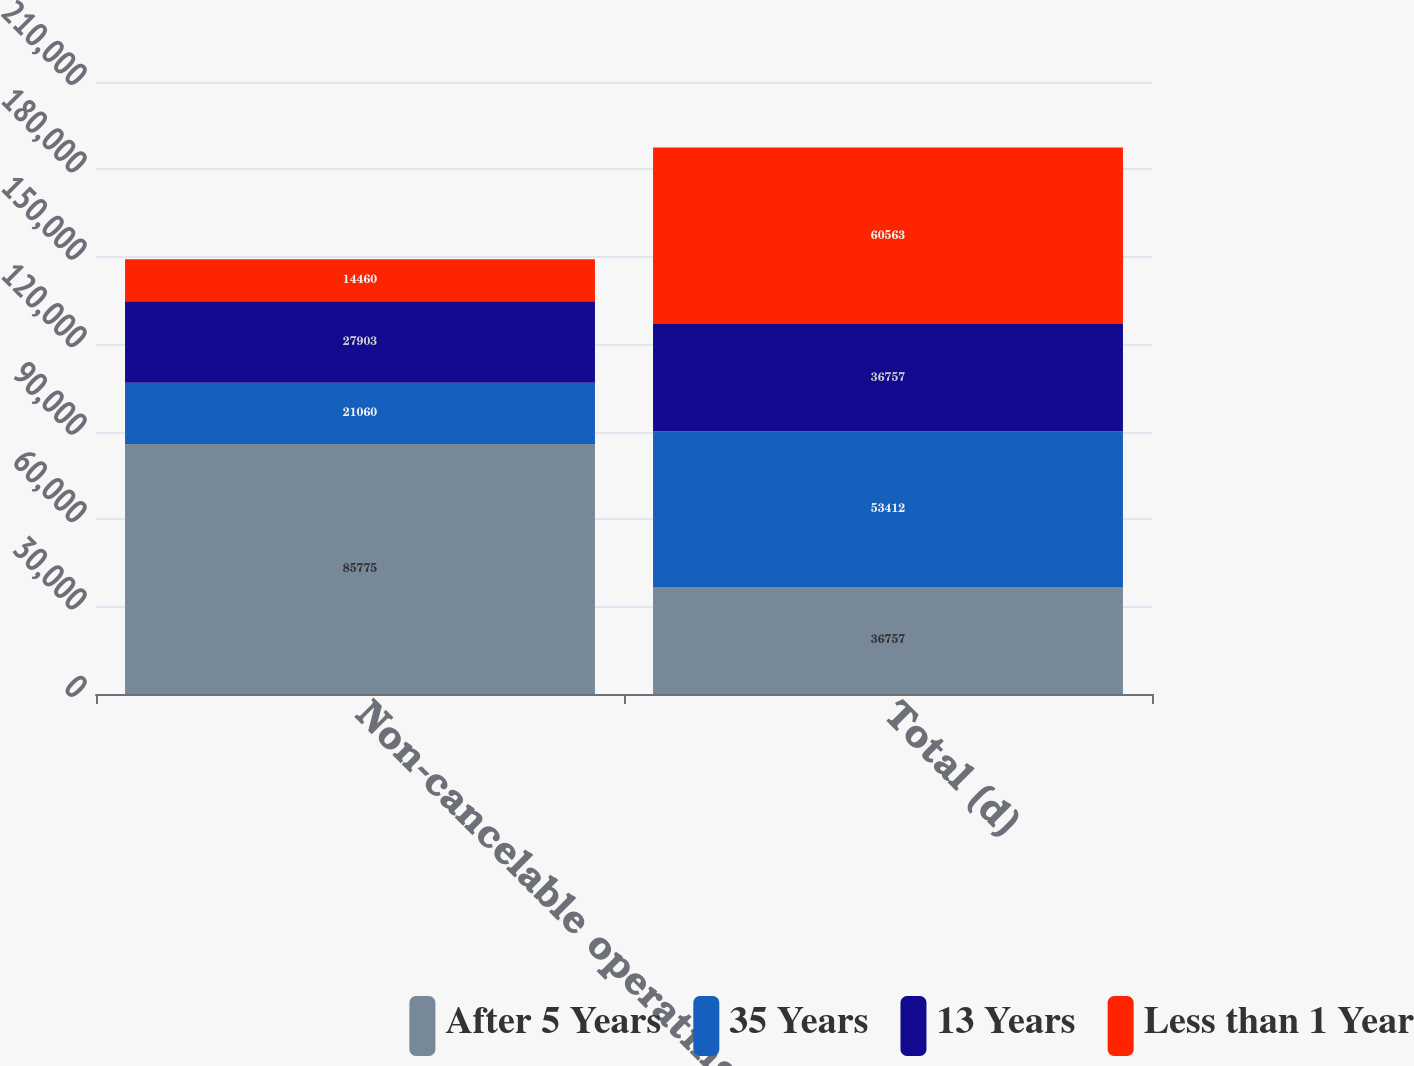Convert chart. <chart><loc_0><loc_0><loc_500><loc_500><stacked_bar_chart><ecel><fcel>Non-cancelable operating<fcel>Total (d)<nl><fcel>After 5 Years<fcel>85775<fcel>36757<nl><fcel>35 Years<fcel>21060<fcel>53412<nl><fcel>13 Years<fcel>27903<fcel>36757<nl><fcel>Less than 1 Year<fcel>14460<fcel>60563<nl></chart> 